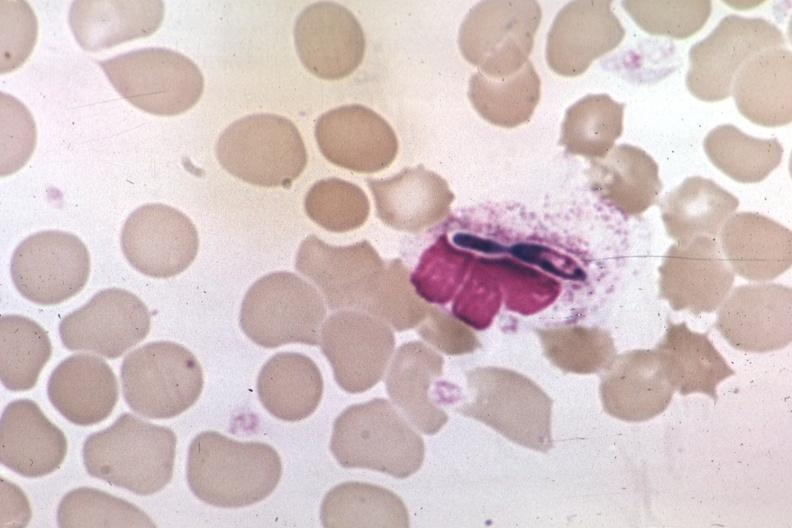does metastatic neuroblastoma show wrights in macrophage?
Answer the question using a single word or phrase. No 